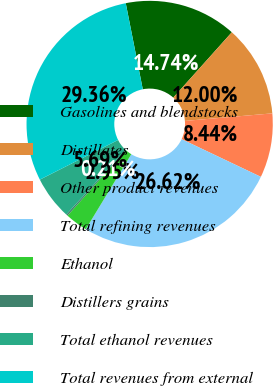<chart> <loc_0><loc_0><loc_500><loc_500><pie_chart><fcel>Gasolines and blendstocks<fcel>Distillates<fcel>Other product revenues<fcel>Total refining revenues<fcel>Ethanol<fcel>Distillers grains<fcel>Total ethanol revenues<fcel>Total revenues from external<nl><fcel>14.74%<fcel>12.0%<fcel>8.44%<fcel>26.62%<fcel>2.95%<fcel>0.21%<fcel>5.69%<fcel>29.36%<nl></chart> 